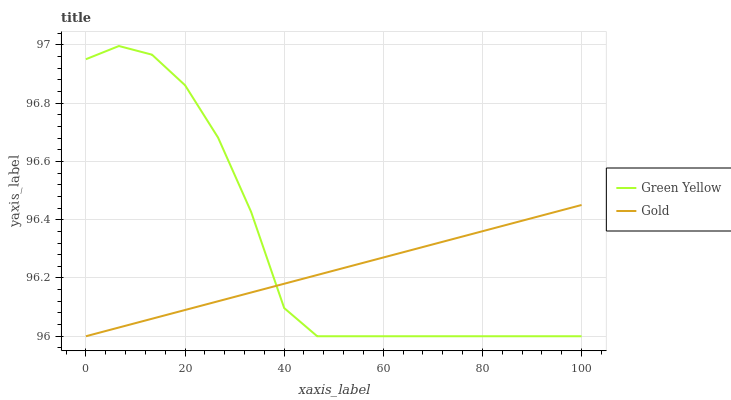Does Gold have the minimum area under the curve?
Answer yes or no. Yes. Does Green Yellow have the maximum area under the curve?
Answer yes or no. Yes. Does Gold have the maximum area under the curve?
Answer yes or no. No. Is Gold the smoothest?
Answer yes or no. Yes. Is Green Yellow the roughest?
Answer yes or no. Yes. Is Gold the roughest?
Answer yes or no. No. Does Green Yellow have the lowest value?
Answer yes or no. Yes. Does Green Yellow have the highest value?
Answer yes or no. Yes. Does Gold have the highest value?
Answer yes or no. No. Does Green Yellow intersect Gold?
Answer yes or no. Yes. Is Green Yellow less than Gold?
Answer yes or no. No. Is Green Yellow greater than Gold?
Answer yes or no. No. 